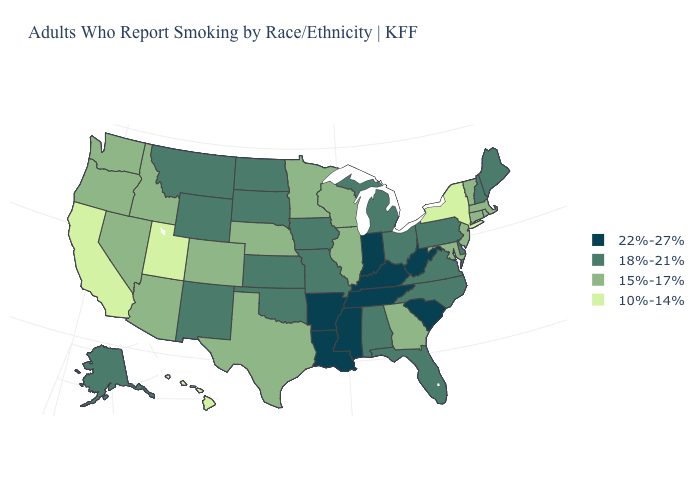What is the lowest value in the West?
Give a very brief answer. 10%-14%. Does the first symbol in the legend represent the smallest category?
Write a very short answer. No. Among the states that border West Virginia , which have the highest value?
Write a very short answer. Kentucky. What is the highest value in states that border Missouri?
Short answer required. 22%-27%. What is the value of Nevada?
Concise answer only. 15%-17%. Does West Virginia have the highest value in the South?
Give a very brief answer. Yes. What is the value of California?
Keep it brief. 10%-14%. Which states hav the highest value in the Northeast?
Short answer required. Maine, New Hampshire, Pennsylvania. Does Oregon have a lower value than Nebraska?
Answer briefly. No. Name the states that have a value in the range 22%-27%?
Write a very short answer. Arkansas, Indiana, Kentucky, Louisiana, Mississippi, South Carolina, Tennessee, West Virginia. Which states hav the highest value in the MidWest?
Quick response, please. Indiana. Among the states that border Minnesota , does North Dakota have the lowest value?
Give a very brief answer. No. Does Utah have the lowest value in the West?
Answer briefly. Yes. Name the states that have a value in the range 18%-21%?
Quick response, please. Alabama, Alaska, Delaware, Florida, Iowa, Kansas, Maine, Michigan, Missouri, Montana, New Hampshire, New Mexico, North Carolina, North Dakota, Ohio, Oklahoma, Pennsylvania, South Dakota, Virginia, Wyoming. Among the states that border Maryland , does West Virginia have the lowest value?
Quick response, please. No. 